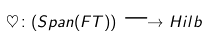<formula> <loc_0><loc_0><loc_500><loc_500>\heartsuit \colon ( S p a n ( F T ) ) \longrightarrow { H i l b }</formula> 